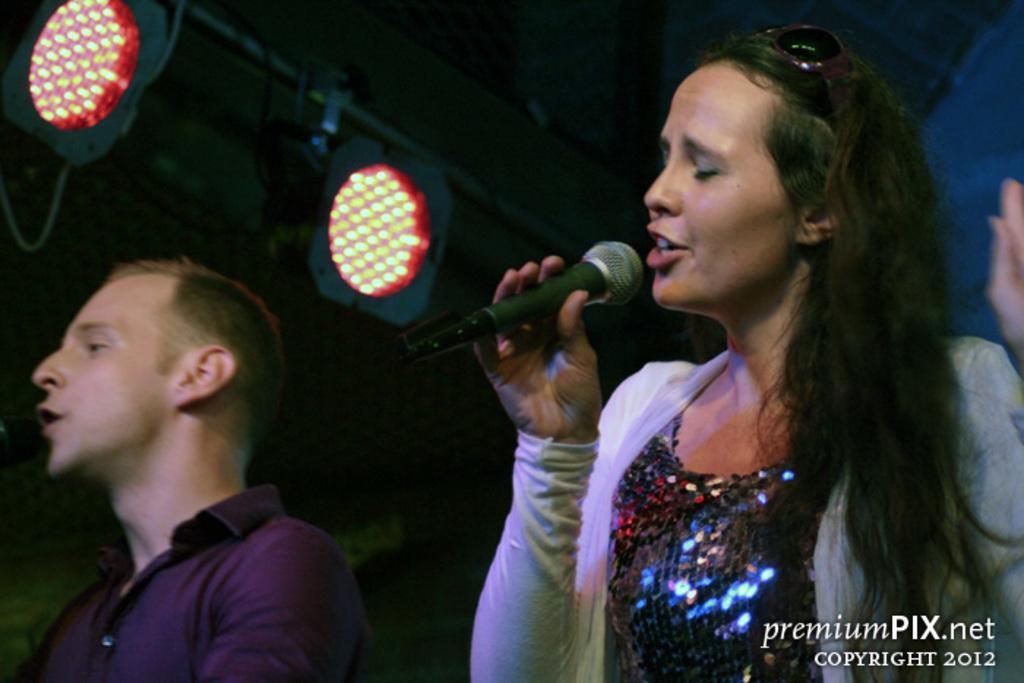Could you give a brief overview of what you see in this image? In the image there were two persons, man and woman. The woman is holding a mike, there were singing. To the left top there were two lights. In the bottom right there is text. 